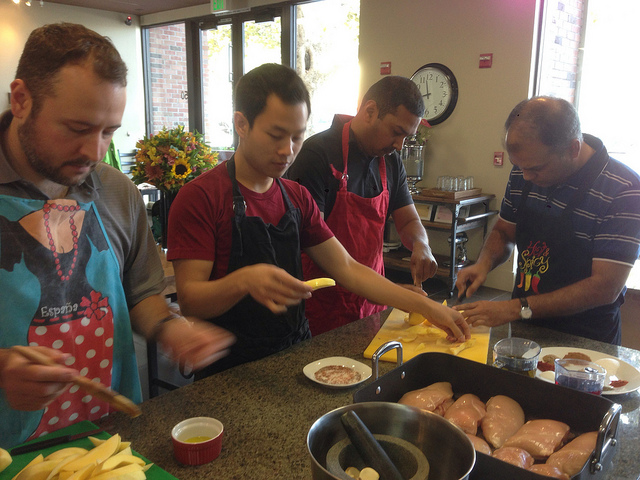How many people are there? There are four people pictured, all engaged in what appears to be a cooking activity, each person focused on preparing different ingredients. 